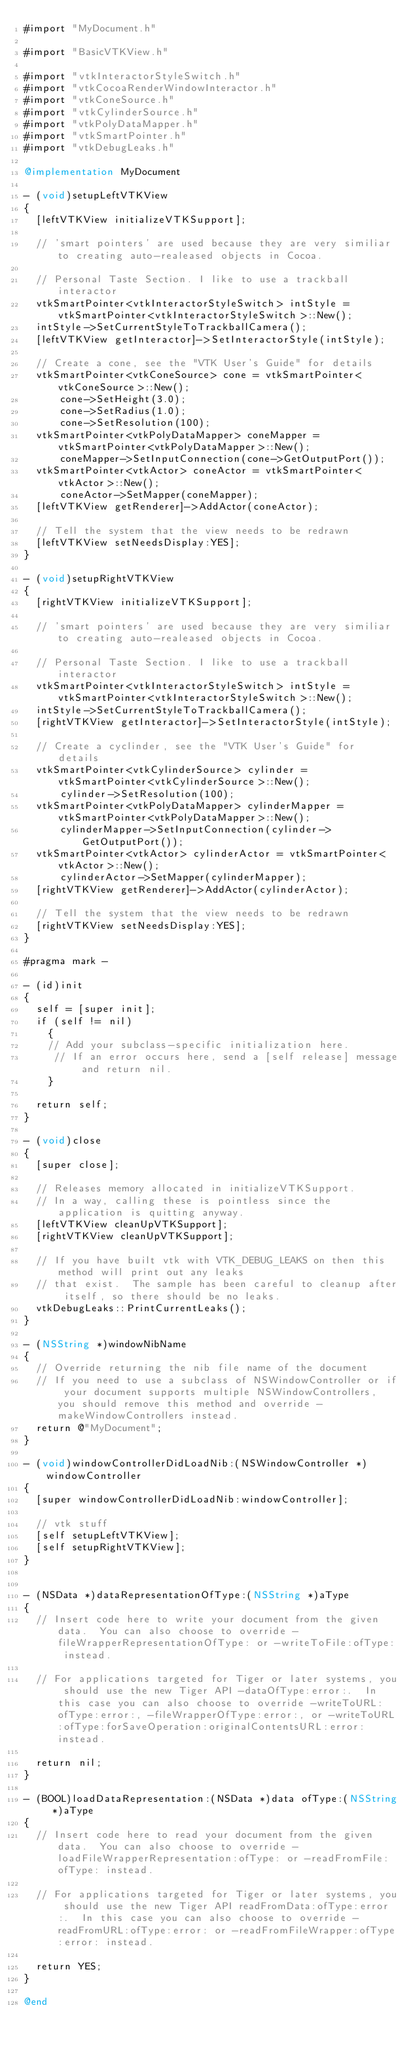<code> <loc_0><loc_0><loc_500><loc_500><_ObjectiveC_>#import "MyDocument.h"

#import "BasicVTKView.h"

#import "vtkInteractorStyleSwitch.h"
#import "vtkCocoaRenderWindowInteractor.h"
#import "vtkConeSource.h"
#import "vtkCylinderSource.h"
#import "vtkPolyDataMapper.h"
#import "vtkSmartPointer.h"
#import "vtkDebugLeaks.h"

@implementation MyDocument

- (void)setupLeftVTKView
{
  [leftVTKView initializeVTKSupport];

  // 'smart pointers' are used because they are very similiar to creating auto-realeased objects in Cocoa.

  // Personal Taste Section. I like to use a trackball interactor
  vtkSmartPointer<vtkInteractorStyleSwitch> intStyle = vtkSmartPointer<vtkInteractorStyleSwitch>::New();
  intStyle->SetCurrentStyleToTrackballCamera();
  [leftVTKView getInteractor]->SetInteractorStyle(intStyle);

  // Create a cone, see the "VTK User's Guide" for details
  vtkSmartPointer<vtkConeSource> cone = vtkSmartPointer<vtkConeSource>::New();
      cone->SetHeight(3.0);
      cone->SetRadius(1.0);
      cone->SetResolution(100);
  vtkSmartPointer<vtkPolyDataMapper> coneMapper = vtkSmartPointer<vtkPolyDataMapper>::New();
      coneMapper->SetInputConnection(cone->GetOutputPort());
  vtkSmartPointer<vtkActor> coneActor = vtkSmartPointer<vtkActor>::New();
      coneActor->SetMapper(coneMapper);
  [leftVTKView getRenderer]->AddActor(coneActor);

  // Tell the system that the view needs to be redrawn
  [leftVTKView setNeedsDisplay:YES];
}

- (void)setupRightVTKView
{
  [rightVTKView initializeVTKSupport];

  // 'smart pointers' are used because they are very similiar to creating auto-realeased objects in Cocoa.

  // Personal Taste Section. I like to use a trackball interactor
  vtkSmartPointer<vtkInteractorStyleSwitch> intStyle = vtkSmartPointer<vtkInteractorStyleSwitch>::New();
  intStyle->SetCurrentStyleToTrackballCamera();
  [rightVTKView getInteractor]->SetInteractorStyle(intStyle);

  // Create a cyclinder, see the "VTK User's Guide" for details
  vtkSmartPointer<vtkCylinderSource> cylinder = vtkSmartPointer<vtkCylinderSource>::New();
      cylinder->SetResolution(100);
  vtkSmartPointer<vtkPolyDataMapper> cylinderMapper = vtkSmartPointer<vtkPolyDataMapper>::New();
      cylinderMapper->SetInputConnection(cylinder->GetOutputPort());
  vtkSmartPointer<vtkActor> cylinderActor = vtkSmartPointer<vtkActor>::New();
      cylinderActor->SetMapper(cylinderMapper);
  [rightVTKView getRenderer]->AddActor(cylinderActor);

  // Tell the system that the view needs to be redrawn
  [rightVTKView setNeedsDisplay:YES];
}

#pragma mark -

- (id)init
{
  self = [super init];
  if (self != nil)
    {
    // Add your subclass-specific initialization here.
     // If an error occurs here, send a [self release] message and return nil.
    }

  return self;
}

- (void)close
{
  [super close];

  // Releases memory allocated in initializeVTKSupport.
  // In a way, calling these is pointless since the application is quitting anyway.
  [leftVTKView cleanUpVTKSupport];
  [rightVTKView cleanUpVTKSupport];

  // If you have built vtk with VTK_DEBUG_LEAKS on then this method will print out any leaks
  // that exist.  The sample has been careful to cleanup after itself, so there should be no leaks.
  vtkDebugLeaks::PrintCurrentLeaks();
}

- (NSString *)windowNibName
{
  // Override returning the nib file name of the document
  // If you need to use a subclass of NSWindowController or if your document supports multiple NSWindowControllers, you should remove this method and override -makeWindowControllers instead.
  return @"MyDocument";
}

- (void)windowControllerDidLoadNib:(NSWindowController *)windowController
{
  [super windowControllerDidLoadNib:windowController];

  // vtk stuff
  [self setupLeftVTKView];
  [self setupRightVTKView];
}


- (NSData *)dataRepresentationOfType:(NSString *)aType
{
  // Insert code here to write your document from the given data.  You can also choose to override -fileWrapperRepresentationOfType: or -writeToFile:ofType: instead.

  // For applications targeted for Tiger or later systems, you should use the new Tiger API -dataOfType:error:.  In this case you can also choose to override -writeToURL:ofType:error:, -fileWrapperOfType:error:, or -writeToURL:ofType:forSaveOperation:originalContentsURL:error: instead.

  return nil;
}

- (BOOL)loadDataRepresentation:(NSData *)data ofType:(NSString *)aType
{
  // Insert code here to read your document from the given data.  You can also choose to override -loadFileWrapperRepresentation:ofType: or -readFromFile:ofType: instead.

  // For applications targeted for Tiger or later systems, you should use the new Tiger API readFromData:ofType:error:.  In this case you can also choose to override -readFromURL:ofType:error: or -readFromFileWrapper:ofType:error: instead.

  return YES;
}

@end
</code> 